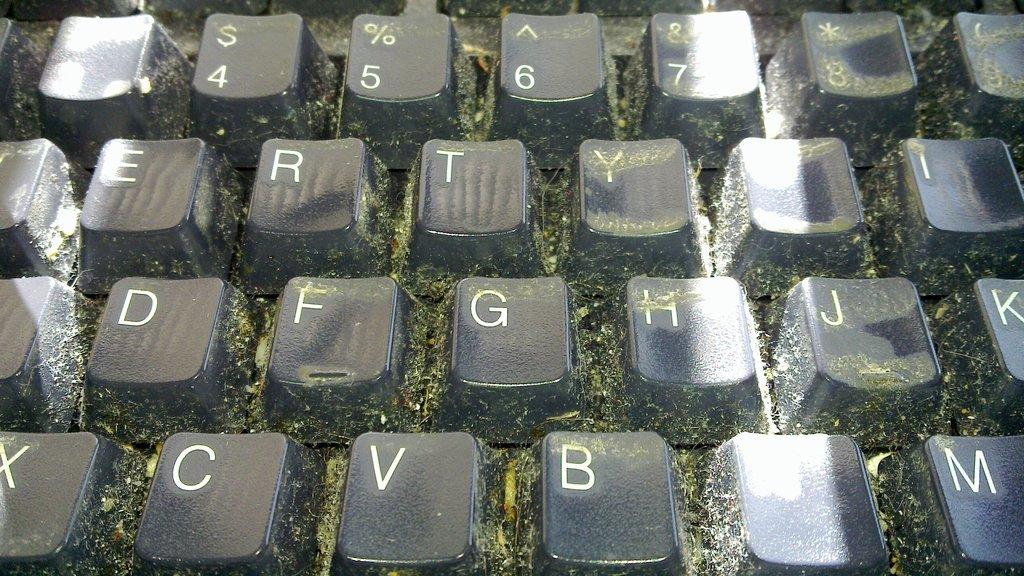What's the bottom 3 keys in the middle?
Make the answer very short. Cvb. The bottom keys are c, v and b?
Give a very brief answer. Yes. 